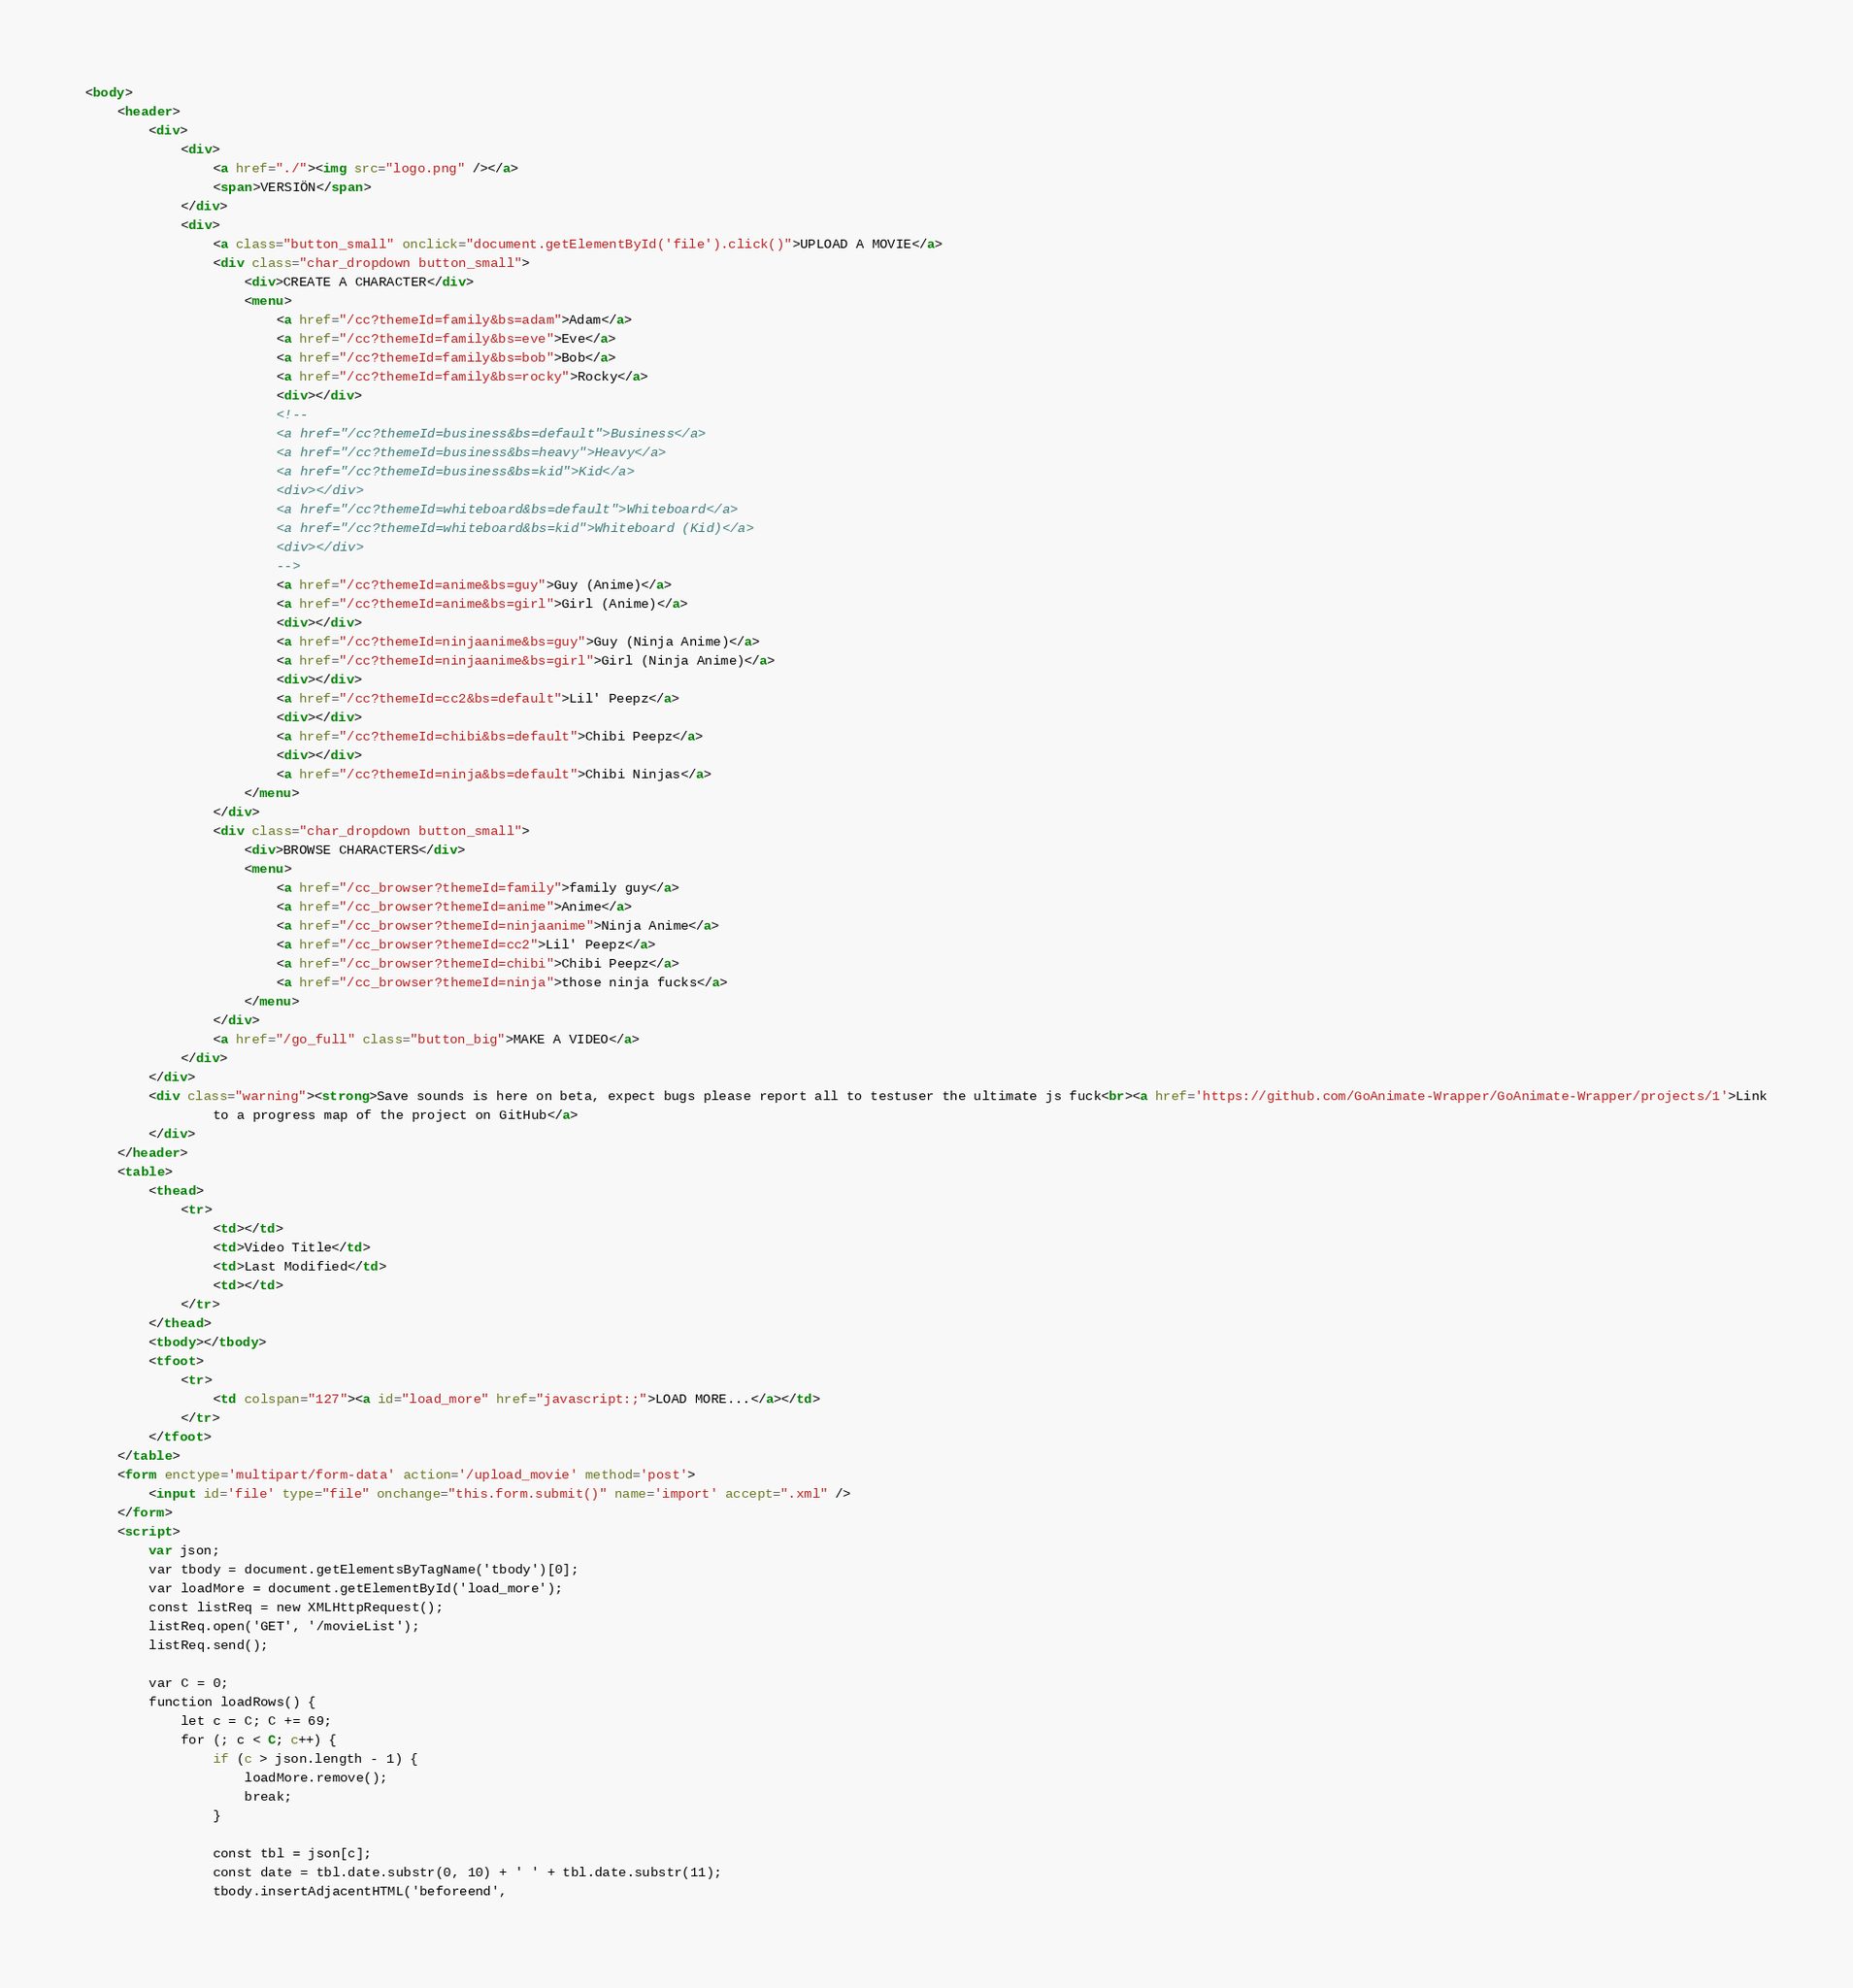Convert code to text. <code><loc_0><loc_0><loc_500><loc_500><_HTML_><body>
	<header>
		<div>
			<div>
				<a href="./"><img src="logo.png" /></a>
				<span>VERSIÖN</span>
			</div>
			<div>
				<a class="button_small" onclick="document.getElementById('file').click()">UPLOAD A MOVIE</a>
				<div class="char_dropdown button_small">
					<div>CREATE A CHARACTER</div>
					<menu>
						<a href="/cc?themeId=family&bs=adam">Adam</a>
						<a href="/cc?themeId=family&bs=eve">Eve</a>
						<a href="/cc?themeId=family&bs=bob">Bob</a>
						<a href="/cc?themeId=family&bs=rocky">Rocky</a>
						<div></div>
						<!--
						<a href="/cc?themeId=business&bs=default">Business</a>
						<a href="/cc?themeId=business&bs=heavy">Heavy</a>
						<a href="/cc?themeId=business&bs=kid">Kid</a>
						<div></div>
						<a href="/cc?themeId=whiteboard&bs=default">Whiteboard</a>
						<a href="/cc?themeId=whiteboard&bs=kid">Whiteboard (Kid)</a>
						<div></div>
						-->
						<a href="/cc?themeId=anime&bs=guy">Guy (Anime)</a>
						<a href="/cc?themeId=anime&bs=girl">Girl (Anime)</a>
						<div></div>
						<a href="/cc?themeId=ninjaanime&bs=guy">Guy (Ninja Anime)</a>
						<a href="/cc?themeId=ninjaanime&bs=girl">Girl (Ninja Anime)</a>
						<div></div>
						<a href="/cc?themeId=cc2&bs=default">Lil' Peepz</a>
						<div></div>
						<a href="/cc?themeId=chibi&bs=default">Chibi Peepz</a>
						<div></div>
						<a href="/cc?themeId=ninja&bs=default">Chibi Ninjas</a>
					</menu>
				</div>
				<div class="char_dropdown button_small">
					<div>BROWSE CHARACTERS</div>
					<menu>
						<a href="/cc_browser?themeId=family">family guy</a>
						<a href="/cc_browser?themeId=anime">Anime</a>
						<a href="/cc_browser?themeId=ninjaanime">Ninja Anime</a>
						<a href="/cc_browser?themeId=cc2">Lil' Peepz</a>
						<a href="/cc_browser?themeId=chibi">Chibi Peepz</a>
						<a href="/cc_browser?themeId=ninja">those ninja fucks</a>
					</menu>
				</div>
				<a href="/go_full" class="button_big">MAKE A VIDEO</a>
			</div>
		</div>
		<div class="warning"><strong>Save sounds is here on beta, expect bugs please report all to testuser the ultimate js fuck<br><a href='https://github.com/GoAnimate-Wrapper/GoAnimate-Wrapper/projects/1'>Link
				to a progress map of the project on GitHub</a>
		</div>
	</header>
	<table>
		<thead>
			<tr>
				<td></td>
				<td>Video Title</td>
				<td>Last Modified</td>
				<td></td>
			</tr>
		</thead>
		<tbody></tbody>
		<tfoot>
			<tr>
				<td colspan="127"><a id="load_more" href="javascript:;">LOAD MORE...</a></td>
			</tr>
		</tfoot>
	</table>
	<form enctype='multipart/form-data' action='/upload_movie' method='post'>
		<input id='file' type="file" onchange="this.form.submit()" name='import' accept=".xml" />
	</form>
	<script>
		var json;
		var tbody = document.getElementsByTagName('tbody')[0];
		var loadMore = document.getElementById('load_more');
		const listReq = new XMLHttpRequest();
		listReq.open('GET', '/movieList');
		listReq.send();

		var C = 0;
		function loadRows() {
			let c = C; C += 69;
			for (; c < C; c++) {
				if (c > json.length - 1) {
					loadMore.remove();
					break;
				}

				const tbl = json[c];
				const date = tbl.date.substr(0, 10) + ' ' + tbl.date.substr(11);
				tbody.insertAdjacentHTML('beforeend',</code> 